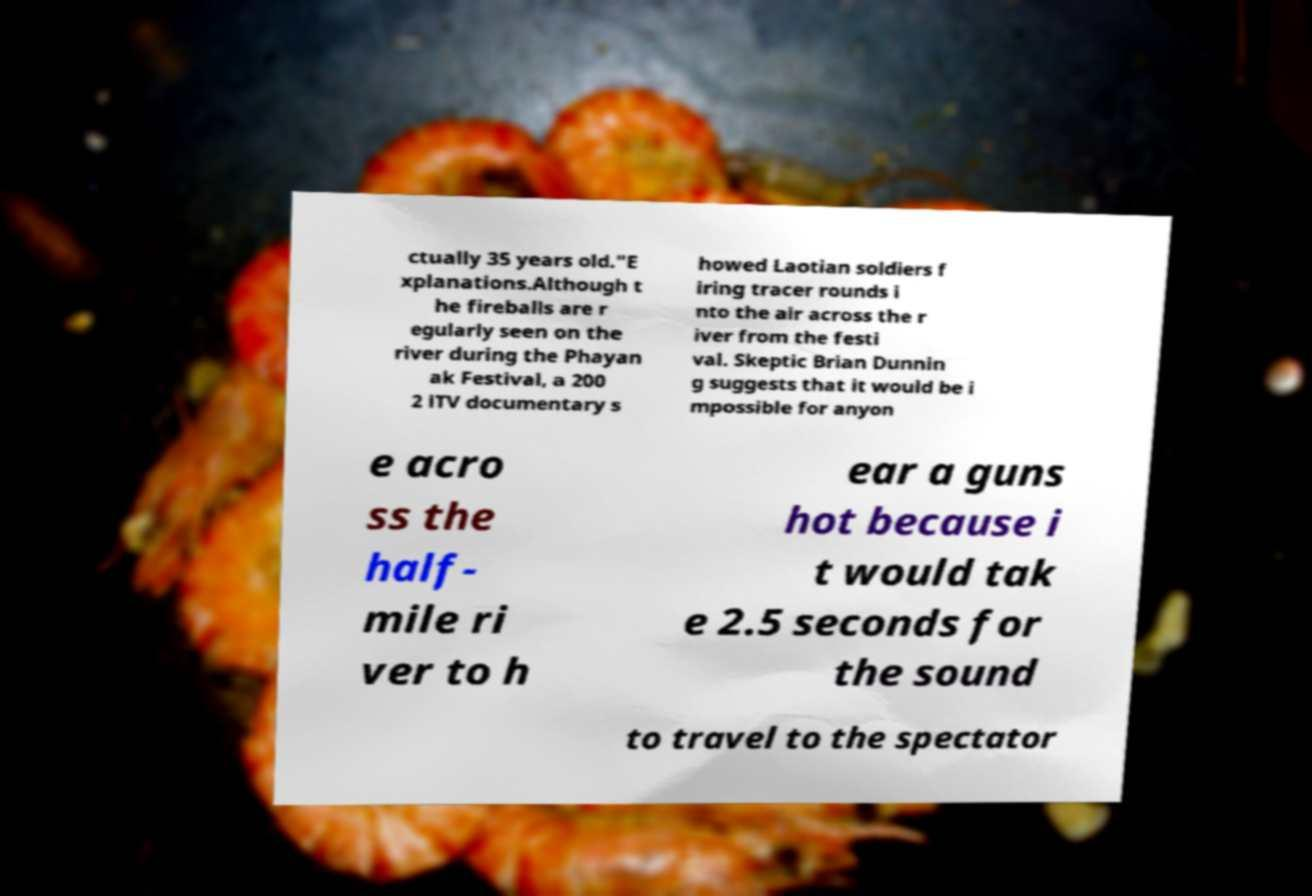Please identify and transcribe the text found in this image. ctually 35 years old."E xplanations.Although t he fireballs are r egularly seen on the river during the Phayan ak Festival, a 200 2 iTV documentary s howed Laotian soldiers f iring tracer rounds i nto the air across the r iver from the festi val. Skeptic Brian Dunnin g suggests that it would be i mpossible for anyon e acro ss the half- mile ri ver to h ear a guns hot because i t would tak e 2.5 seconds for the sound to travel to the spectator 